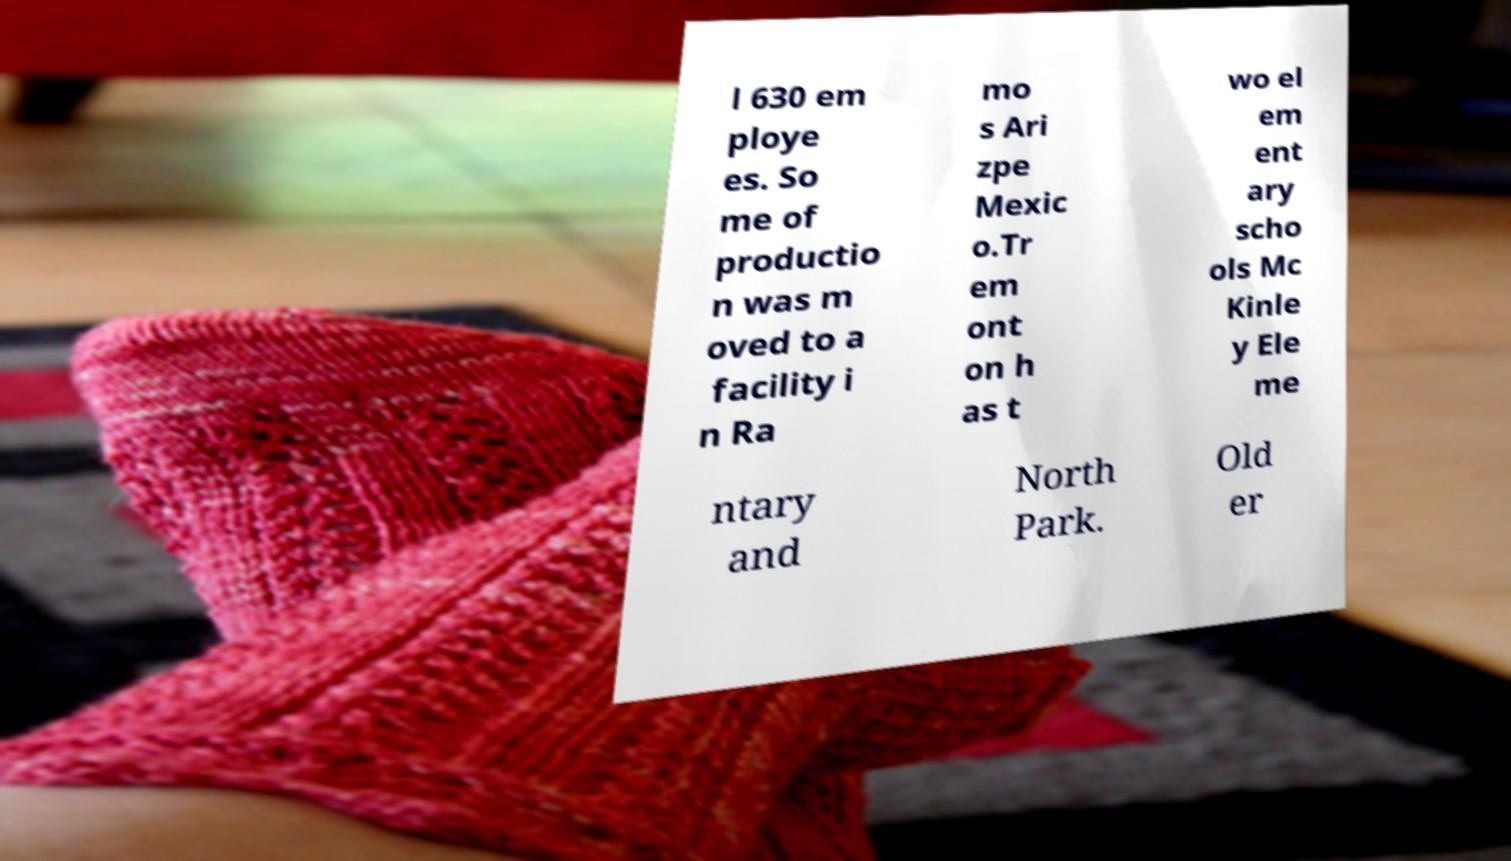Please identify and transcribe the text found in this image. l 630 em ploye es. So me of productio n was m oved to a facility i n Ra mo s Ari zpe Mexic o.Tr em ont on h as t wo el em ent ary scho ols Mc Kinle y Ele me ntary and North Park. Old er 